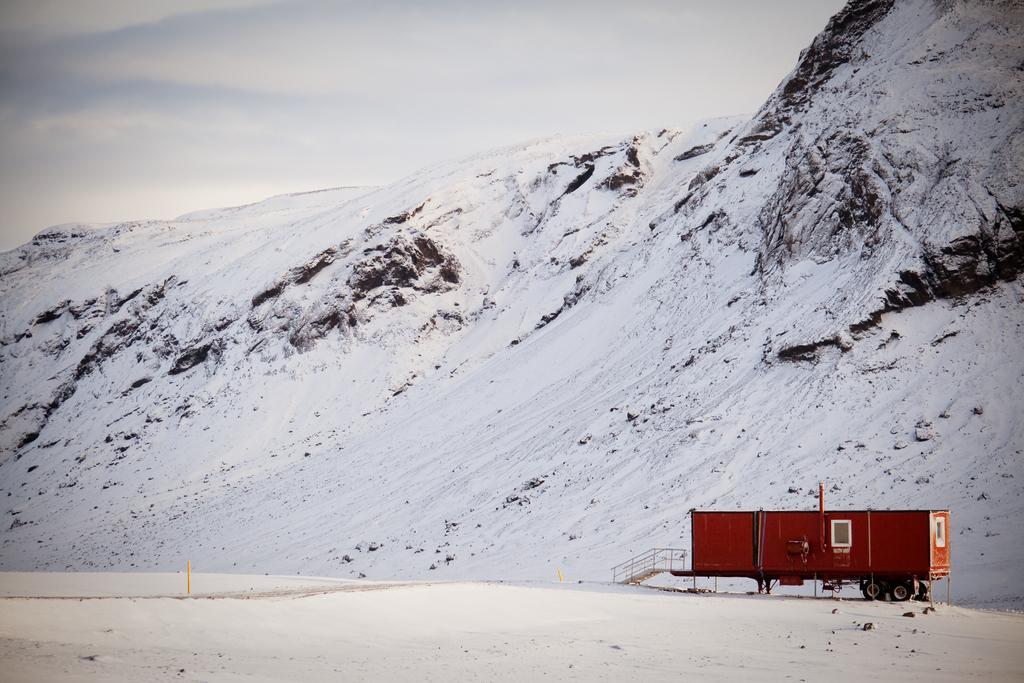In one or two sentences, can you explain what this image depicts? At the right side of the image there is a container. At the bottom of the image there is snow. At the background of the image there is a snow mountain. At the top of the image there are clouds. 